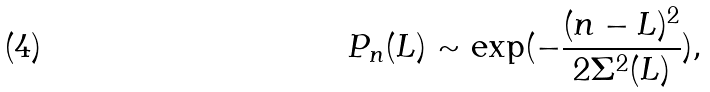<formula> <loc_0><loc_0><loc_500><loc_500>P _ { n } ( L ) \sim \exp ( - \frac { ( n - L ) ^ { 2 } } { 2 \Sigma ^ { 2 } ( L ) } ) ,</formula> 